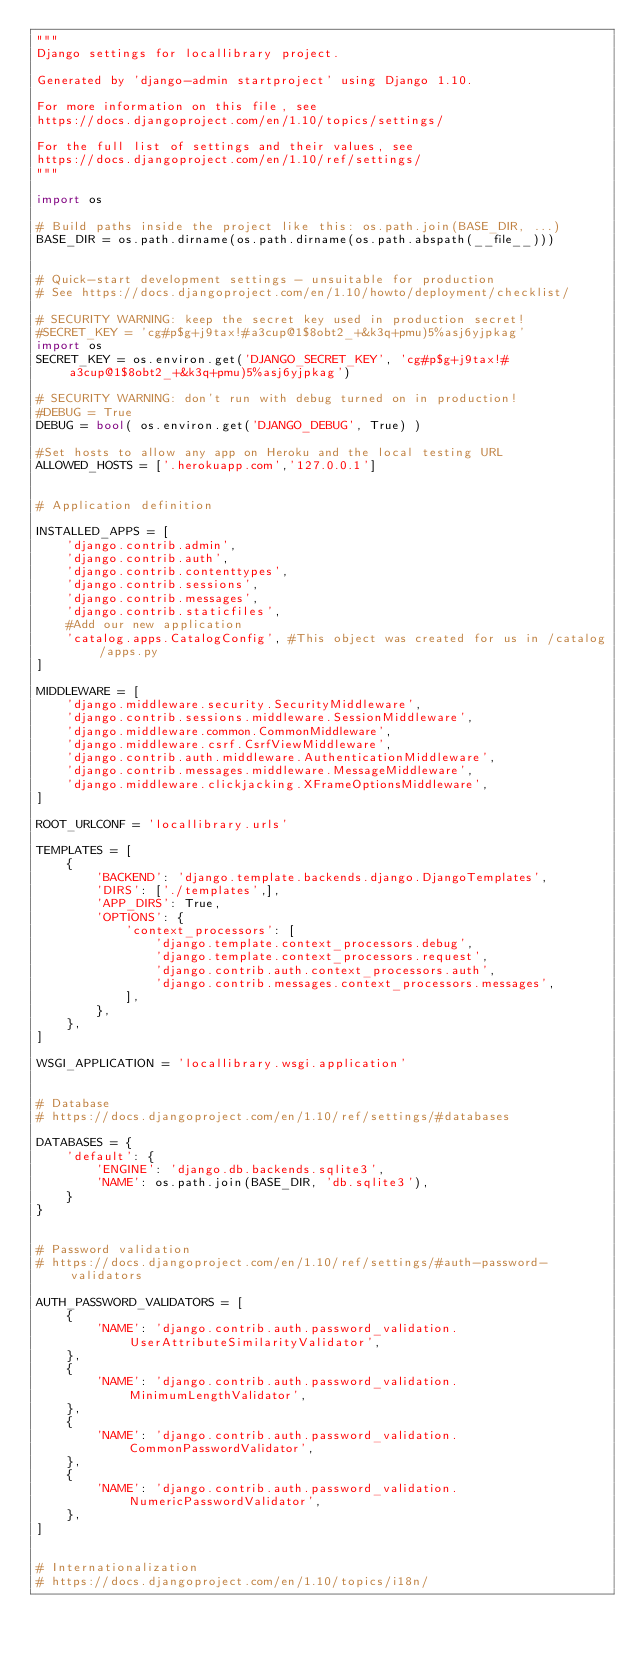<code> <loc_0><loc_0><loc_500><loc_500><_Python_>"""
Django settings for locallibrary project.

Generated by 'django-admin startproject' using Django 1.10.

For more information on this file, see
https://docs.djangoproject.com/en/1.10/topics/settings/

For the full list of settings and their values, see
https://docs.djangoproject.com/en/1.10/ref/settings/
"""

import os

# Build paths inside the project like this: os.path.join(BASE_DIR, ...)
BASE_DIR = os.path.dirname(os.path.dirname(os.path.abspath(__file__)))


# Quick-start development settings - unsuitable for production
# See https://docs.djangoproject.com/en/1.10/howto/deployment/checklist/

# SECURITY WARNING: keep the secret key used in production secret!
#SECRET_KEY = 'cg#p$g+j9tax!#a3cup@1$8obt2_+&k3q+pmu)5%asj6yjpkag'
import os
SECRET_KEY = os.environ.get('DJANGO_SECRET_KEY', 'cg#p$g+j9tax!#a3cup@1$8obt2_+&k3q+pmu)5%asj6yjpkag')

# SECURITY WARNING: don't run with debug turned on in production!
#DEBUG = True
DEBUG = bool( os.environ.get('DJANGO_DEBUG', True) )

#Set hosts to allow any app on Heroku and the local testing URL
ALLOWED_HOSTS = ['.herokuapp.com','127.0.0.1']


# Application definition

INSTALLED_APPS = [
    'django.contrib.admin',
    'django.contrib.auth',
    'django.contrib.contenttypes',
    'django.contrib.sessions',
    'django.contrib.messages',
    'django.contrib.staticfiles',
    #Add our new application 
    'catalog.apps.CatalogConfig', #This object was created for us in /catalog/apps.py
]

MIDDLEWARE = [
    'django.middleware.security.SecurityMiddleware',
    'django.contrib.sessions.middleware.SessionMiddleware',
    'django.middleware.common.CommonMiddleware',
    'django.middleware.csrf.CsrfViewMiddleware',
    'django.contrib.auth.middleware.AuthenticationMiddleware',
    'django.contrib.messages.middleware.MessageMiddleware',
    'django.middleware.clickjacking.XFrameOptionsMiddleware',
]

ROOT_URLCONF = 'locallibrary.urls'

TEMPLATES = [
    {
        'BACKEND': 'django.template.backends.django.DjangoTemplates',
        'DIRS': ['./templates',],
        'APP_DIRS': True,
        'OPTIONS': {
            'context_processors': [
                'django.template.context_processors.debug',
                'django.template.context_processors.request',
                'django.contrib.auth.context_processors.auth',
                'django.contrib.messages.context_processors.messages',
            ],
        },
    },
]

WSGI_APPLICATION = 'locallibrary.wsgi.application'


# Database
# https://docs.djangoproject.com/en/1.10/ref/settings/#databases

DATABASES = {
    'default': {
        'ENGINE': 'django.db.backends.sqlite3',
        'NAME': os.path.join(BASE_DIR, 'db.sqlite3'),
    }
}


# Password validation
# https://docs.djangoproject.com/en/1.10/ref/settings/#auth-password-validators

AUTH_PASSWORD_VALIDATORS = [
    {
        'NAME': 'django.contrib.auth.password_validation.UserAttributeSimilarityValidator',
    },
    {
        'NAME': 'django.contrib.auth.password_validation.MinimumLengthValidator',
    },
    {
        'NAME': 'django.contrib.auth.password_validation.CommonPasswordValidator',
    },
    {
        'NAME': 'django.contrib.auth.password_validation.NumericPasswordValidator',
    },
]


# Internationalization
# https://docs.djangoproject.com/en/1.10/topics/i18n/
</code> 